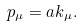<formula> <loc_0><loc_0><loc_500><loc_500>p _ { \mu } = a k _ { \mu } .</formula> 